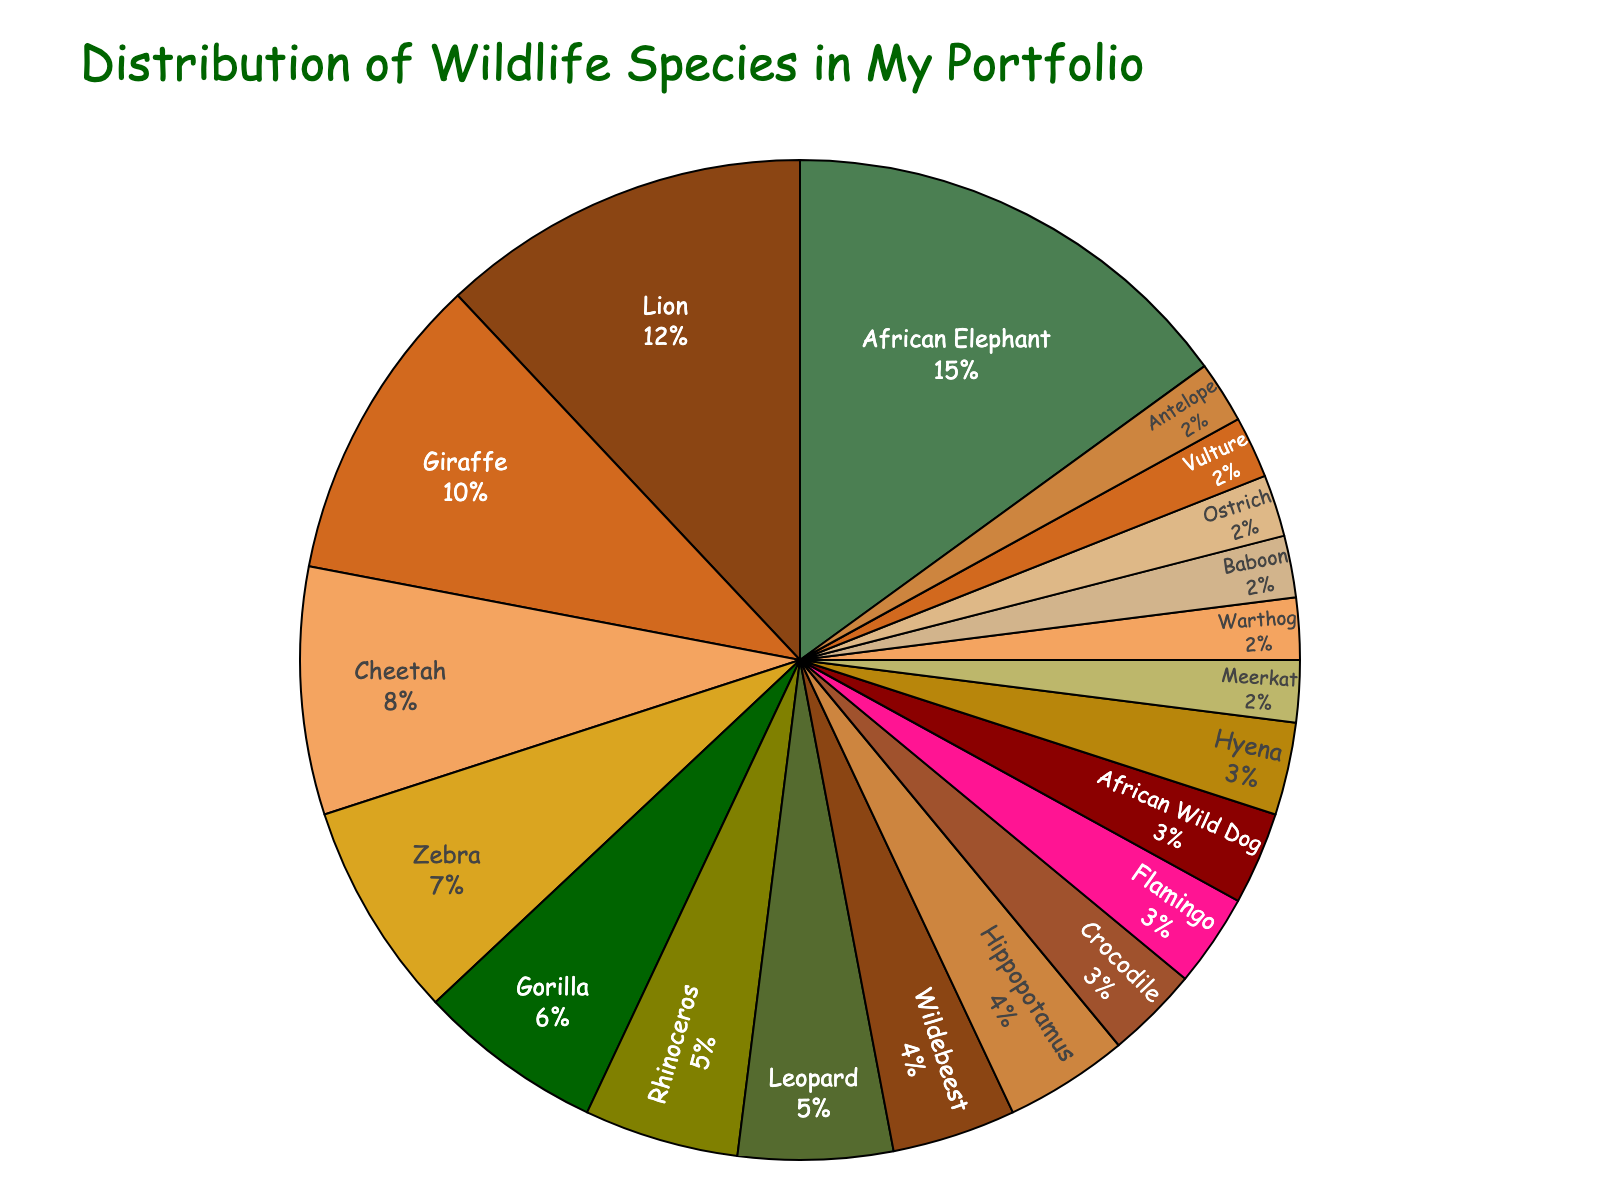What's the percentage of the top three most captured wildlife species in the portfolio combined? The top three most captured wildlife species are African Elephant (15%), Lion (12%), and Giraffe (10%). Adding their percentages together: 15 + 12 + 10 = 37%.
Answer: 37% Which species has a smaller percentage captured, Zebra or Cheetah? The chart shows Zebra at 7% and Cheetah at 8%. Since 7 is smaller than 8, Zebra has a smaller percentage captured.
Answer: Zebra How many species have a capturing percentage of 3%? The chart shows Crocodile, Flamingo, African Wild Dog, and Hyena each with a capturing percentage of 3%. There are 4 species with 3% each.
Answer: 4 What is the difference in capturing percentage between the most and least captured species? The most captured species is African Elephant with 15%, and the least captured species are Meerkat, Warthog, Baboon, Ostrich, Vulture, and Antelope with 2% each. The difference is 15 - 2 = 13%.
Answer: 13% Are there more species captured at 3% or at 2%? There are 4 species captured at 3% and 6 species captured at 2%. Since 6 is more than 4, there are more species captured at 2%.
Answer: 2% Which species have the same capturing percentage as the Ostrich? The data shows that Ostrich is captured at 2%. The other species with 2% are Meerkat, Warthog, Baboon, Vulture, and Antelope. So they have the same percentage as Ostrich.
Answer: Meerkat, Warthog, Baboon, Vulture, Antelope What is the combined percentage of the species captured less than or equal to 4%? From the chart, the species captured at or below 4% are Wildebeest (4%), Hippopotamus (4%), Crocodile (3%), Flamingo (3%), African Wild Dog (3%), Hyena (3%), Meerkat (2%), Warthog (2%), Baboon (2%), Ostrich (2%), Vulture (2%), and Antelope (2%). Adding these: 4 + 4 + 3 + 3 + 3 + 3 + 2 + 2 + 2 + 2 + 2 + 2 = 34%.
Answer: 34% Which percentage is larger, the combined percentage of species captured at exactly 3% or the percentage of African Elephant? The combined percentage of species captured at exactly 3% (Crocodile, Flamingo, African Wild Dog, Hyena) is 3 + 3 + 3 + 3 = 12%. The percentage of African Elephant is 15%. Since 15% is larger than 12%, the African Elephant percentage is larger.
Answer: African Elephant 